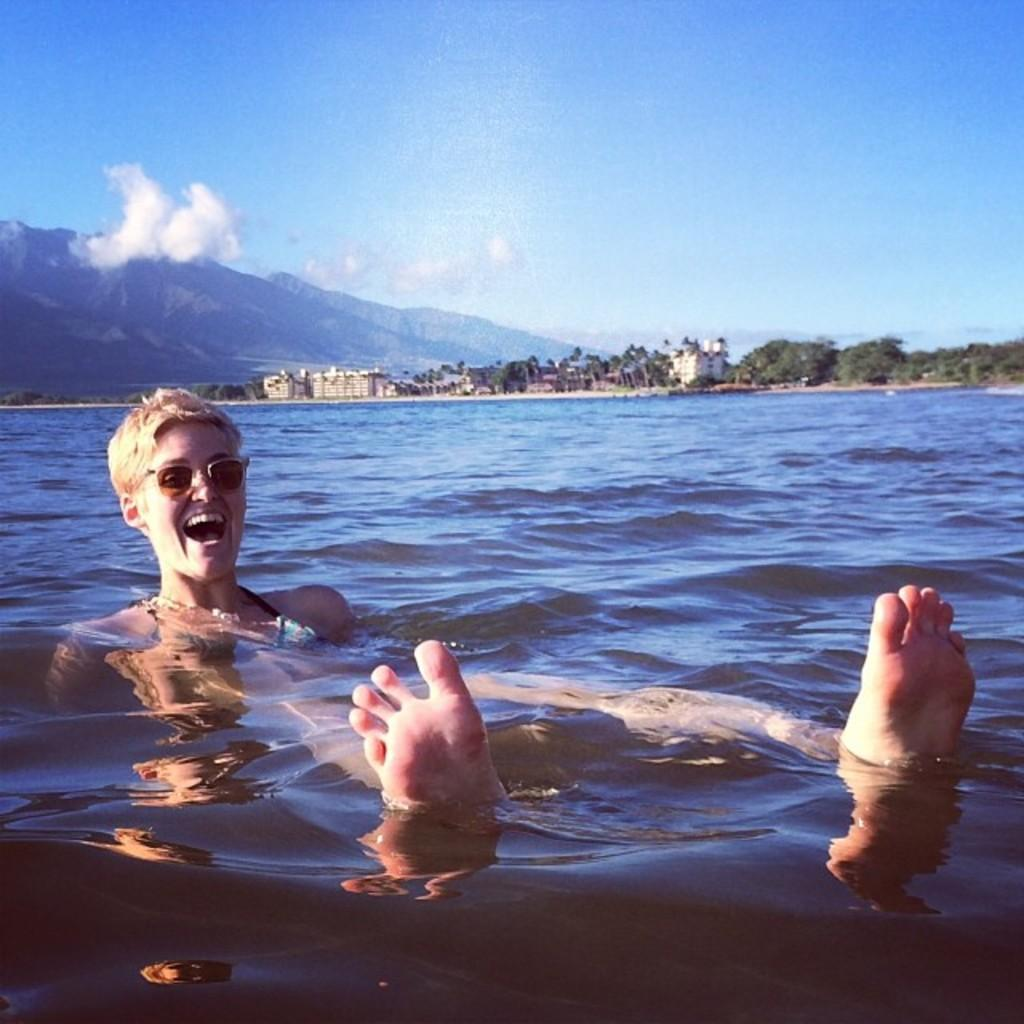What is the primary element present in the image? There is water in the image. Who or what is in the water? There is a woman in the water. What can be seen in the background of the image? There are trees, buildings, mountains, and the sky visible in the background of the image. What type of beginner's selection can be seen on the shelf in the image? There is no shelf or selection present in the image. 